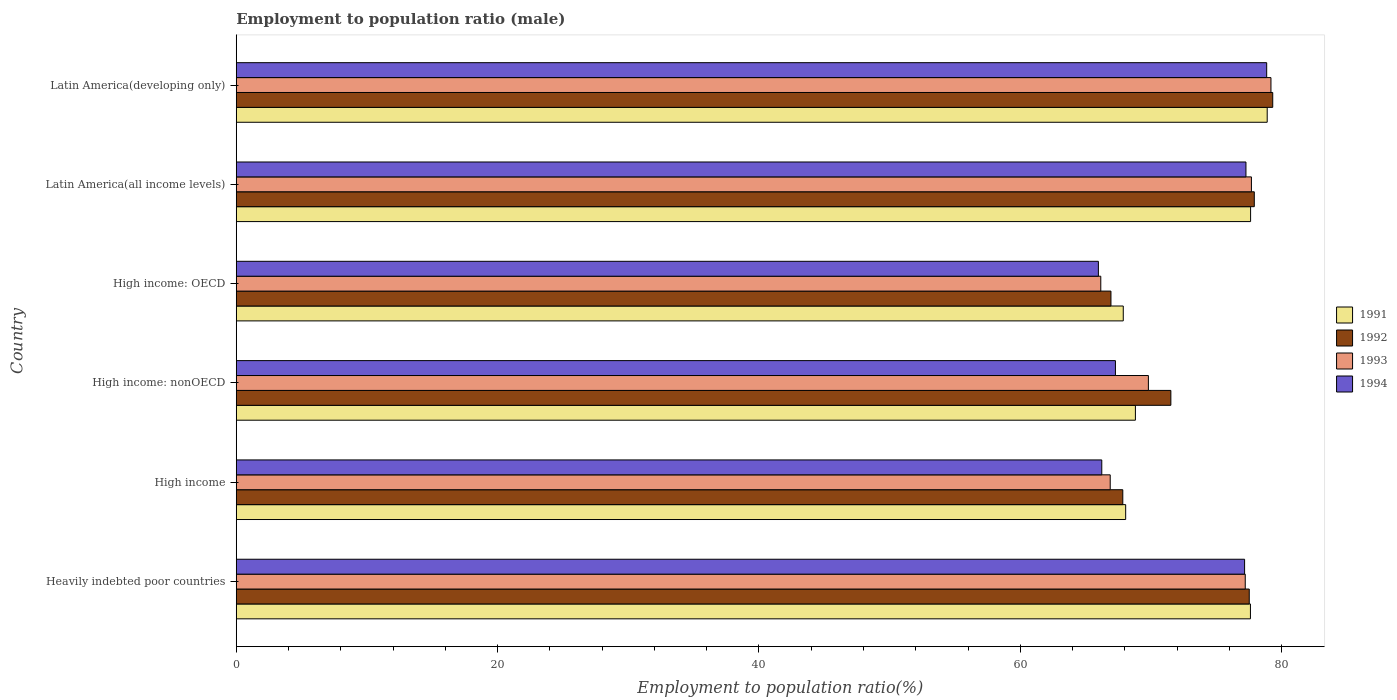Are the number of bars per tick equal to the number of legend labels?
Provide a short and direct response. Yes. Are the number of bars on each tick of the Y-axis equal?
Make the answer very short. Yes. What is the label of the 2nd group of bars from the top?
Provide a succinct answer. Latin America(all income levels). What is the employment to population ratio in 1993 in High income?
Keep it short and to the point. 66.88. Across all countries, what is the maximum employment to population ratio in 1994?
Offer a very short reply. 78.86. Across all countries, what is the minimum employment to population ratio in 1992?
Your response must be concise. 66.94. In which country was the employment to population ratio in 1992 maximum?
Make the answer very short. Latin America(developing only). In which country was the employment to population ratio in 1991 minimum?
Your answer should be compact. High income: OECD. What is the total employment to population ratio in 1992 in the graph?
Your answer should be very brief. 441.07. What is the difference between the employment to population ratio in 1994 in High income: OECD and that in High income: nonOECD?
Your response must be concise. -1.31. What is the difference between the employment to population ratio in 1994 in Heavily indebted poor countries and the employment to population ratio in 1993 in High income: OECD?
Provide a short and direct response. 11.01. What is the average employment to population ratio in 1991 per country?
Your response must be concise. 73.15. What is the difference between the employment to population ratio in 1994 and employment to population ratio in 1993 in Latin America(developing only)?
Keep it short and to the point. -0.33. What is the ratio of the employment to population ratio in 1994 in High income to that in Latin America(developing only)?
Offer a terse response. 0.84. Is the employment to population ratio in 1991 in High income less than that in High income: nonOECD?
Your answer should be very brief. Yes. Is the difference between the employment to population ratio in 1994 in High income and High income: nonOECD greater than the difference between the employment to population ratio in 1993 in High income and High income: nonOECD?
Your answer should be compact. Yes. What is the difference between the highest and the second highest employment to population ratio in 1991?
Provide a succinct answer. 1.27. What is the difference between the highest and the lowest employment to population ratio in 1992?
Make the answer very short. 12.38. In how many countries, is the employment to population ratio in 1993 greater than the average employment to population ratio in 1993 taken over all countries?
Ensure brevity in your answer.  3. Is the sum of the employment to population ratio in 1992 in Latin America(all income levels) and Latin America(developing only) greater than the maximum employment to population ratio in 1991 across all countries?
Offer a terse response. Yes. What does the 3rd bar from the top in Latin America(developing only) represents?
Offer a terse response. 1992. Is it the case that in every country, the sum of the employment to population ratio in 1992 and employment to population ratio in 1993 is greater than the employment to population ratio in 1991?
Your response must be concise. Yes. How many bars are there?
Provide a short and direct response. 24. Are all the bars in the graph horizontal?
Offer a very short reply. Yes. How many countries are there in the graph?
Give a very brief answer. 6. What is the difference between two consecutive major ticks on the X-axis?
Make the answer very short. 20. Does the graph contain any zero values?
Your answer should be compact. No. Does the graph contain grids?
Your answer should be very brief. No. How many legend labels are there?
Keep it short and to the point. 4. What is the title of the graph?
Your answer should be very brief. Employment to population ratio (male). What is the label or title of the X-axis?
Your answer should be very brief. Employment to population ratio(%). What is the label or title of the Y-axis?
Give a very brief answer. Country. What is the Employment to population ratio(%) in 1991 in Heavily indebted poor countries?
Ensure brevity in your answer.  77.61. What is the Employment to population ratio(%) of 1992 in Heavily indebted poor countries?
Your response must be concise. 77.52. What is the Employment to population ratio(%) in 1993 in Heavily indebted poor countries?
Make the answer very short. 77.22. What is the Employment to population ratio(%) of 1994 in Heavily indebted poor countries?
Your response must be concise. 77.17. What is the Employment to population ratio(%) in 1991 in High income?
Ensure brevity in your answer.  68.07. What is the Employment to population ratio(%) in 1992 in High income?
Keep it short and to the point. 67.85. What is the Employment to population ratio(%) of 1993 in High income?
Your answer should be compact. 66.88. What is the Employment to population ratio(%) in 1994 in High income?
Offer a terse response. 66.24. What is the Employment to population ratio(%) of 1991 in High income: nonOECD?
Offer a very short reply. 68.81. What is the Employment to population ratio(%) of 1992 in High income: nonOECD?
Offer a very short reply. 71.53. What is the Employment to population ratio(%) in 1993 in High income: nonOECD?
Make the answer very short. 69.81. What is the Employment to population ratio(%) in 1994 in High income: nonOECD?
Provide a succinct answer. 67.28. What is the Employment to population ratio(%) in 1991 in High income: OECD?
Offer a terse response. 67.88. What is the Employment to population ratio(%) in 1992 in High income: OECD?
Make the answer very short. 66.94. What is the Employment to population ratio(%) of 1993 in High income: OECD?
Your answer should be very brief. 66.16. What is the Employment to population ratio(%) of 1994 in High income: OECD?
Provide a succinct answer. 65.98. What is the Employment to population ratio(%) of 1991 in Latin America(all income levels)?
Make the answer very short. 77.63. What is the Employment to population ratio(%) in 1992 in Latin America(all income levels)?
Keep it short and to the point. 77.91. What is the Employment to population ratio(%) of 1993 in Latin America(all income levels)?
Make the answer very short. 77.69. What is the Employment to population ratio(%) of 1994 in Latin America(all income levels)?
Give a very brief answer. 77.27. What is the Employment to population ratio(%) in 1991 in Latin America(developing only)?
Your answer should be compact. 78.9. What is the Employment to population ratio(%) in 1992 in Latin America(developing only)?
Your answer should be very brief. 79.32. What is the Employment to population ratio(%) in 1993 in Latin America(developing only)?
Give a very brief answer. 79.19. What is the Employment to population ratio(%) in 1994 in Latin America(developing only)?
Give a very brief answer. 78.86. Across all countries, what is the maximum Employment to population ratio(%) in 1991?
Provide a short and direct response. 78.9. Across all countries, what is the maximum Employment to population ratio(%) of 1992?
Make the answer very short. 79.32. Across all countries, what is the maximum Employment to population ratio(%) in 1993?
Ensure brevity in your answer.  79.19. Across all countries, what is the maximum Employment to population ratio(%) of 1994?
Provide a succinct answer. 78.86. Across all countries, what is the minimum Employment to population ratio(%) of 1991?
Ensure brevity in your answer.  67.88. Across all countries, what is the minimum Employment to population ratio(%) in 1992?
Your response must be concise. 66.94. Across all countries, what is the minimum Employment to population ratio(%) in 1993?
Your answer should be compact. 66.16. Across all countries, what is the minimum Employment to population ratio(%) in 1994?
Provide a short and direct response. 65.98. What is the total Employment to population ratio(%) in 1991 in the graph?
Your answer should be very brief. 438.9. What is the total Employment to population ratio(%) of 1992 in the graph?
Give a very brief answer. 441.07. What is the total Employment to population ratio(%) of 1993 in the graph?
Provide a succinct answer. 436.95. What is the total Employment to population ratio(%) of 1994 in the graph?
Provide a succinct answer. 432.8. What is the difference between the Employment to population ratio(%) in 1991 in Heavily indebted poor countries and that in High income?
Provide a short and direct response. 9.55. What is the difference between the Employment to population ratio(%) of 1992 in Heavily indebted poor countries and that in High income?
Your answer should be compact. 9.68. What is the difference between the Employment to population ratio(%) in 1993 in Heavily indebted poor countries and that in High income?
Make the answer very short. 10.33. What is the difference between the Employment to population ratio(%) of 1994 in Heavily indebted poor countries and that in High income?
Offer a terse response. 10.93. What is the difference between the Employment to population ratio(%) of 1991 in Heavily indebted poor countries and that in High income: nonOECD?
Provide a short and direct response. 8.8. What is the difference between the Employment to population ratio(%) in 1992 in Heavily indebted poor countries and that in High income: nonOECD?
Keep it short and to the point. 6. What is the difference between the Employment to population ratio(%) of 1993 in Heavily indebted poor countries and that in High income: nonOECD?
Your answer should be very brief. 7.41. What is the difference between the Employment to population ratio(%) of 1994 in Heavily indebted poor countries and that in High income: nonOECD?
Your answer should be compact. 9.88. What is the difference between the Employment to population ratio(%) in 1991 in Heavily indebted poor countries and that in High income: OECD?
Ensure brevity in your answer.  9.73. What is the difference between the Employment to population ratio(%) of 1992 in Heavily indebted poor countries and that in High income: OECD?
Offer a very short reply. 10.58. What is the difference between the Employment to population ratio(%) of 1993 in Heavily indebted poor countries and that in High income: OECD?
Your answer should be very brief. 11.06. What is the difference between the Employment to population ratio(%) in 1994 in Heavily indebted poor countries and that in High income: OECD?
Provide a succinct answer. 11.19. What is the difference between the Employment to population ratio(%) of 1991 in Heavily indebted poor countries and that in Latin America(all income levels)?
Provide a short and direct response. -0.01. What is the difference between the Employment to population ratio(%) in 1992 in Heavily indebted poor countries and that in Latin America(all income levels)?
Your answer should be compact. -0.39. What is the difference between the Employment to population ratio(%) of 1993 in Heavily indebted poor countries and that in Latin America(all income levels)?
Your answer should be compact. -0.47. What is the difference between the Employment to population ratio(%) in 1994 in Heavily indebted poor countries and that in Latin America(all income levels)?
Provide a succinct answer. -0.1. What is the difference between the Employment to population ratio(%) in 1991 in Heavily indebted poor countries and that in Latin America(developing only)?
Your response must be concise. -1.28. What is the difference between the Employment to population ratio(%) in 1992 in Heavily indebted poor countries and that in Latin America(developing only)?
Make the answer very short. -1.8. What is the difference between the Employment to population ratio(%) in 1993 in Heavily indebted poor countries and that in Latin America(developing only)?
Offer a terse response. -1.97. What is the difference between the Employment to population ratio(%) in 1994 in Heavily indebted poor countries and that in Latin America(developing only)?
Your answer should be very brief. -1.69. What is the difference between the Employment to population ratio(%) in 1991 in High income and that in High income: nonOECD?
Provide a succinct answer. -0.74. What is the difference between the Employment to population ratio(%) of 1992 in High income and that in High income: nonOECD?
Your answer should be compact. -3.68. What is the difference between the Employment to population ratio(%) of 1993 in High income and that in High income: nonOECD?
Provide a short and direct response. -2.92. What is the difference between the Employment to population ratio(%) of 1994 in High income and that in High income: nonOECD?
Ensure brevity in your answer.  -1.05. What is the difference between the Employment to population ratio(%) in 1991 in High income and that in High income: OECD?
Offer a very short reply. 0.18. What is the difference between the Employment to population ratio(%) in 1992 in High income and that in High income: OECD?
Offer a terse response. 0.91. What is the difference between the Employment to population ratio(%) of 1993 in High income and that in High income: OECD?
Your answer should be very brief. 0.72. What is the difference between the Employment to population ratio(%) in 1994 in High income and that in High income: OECD?
Make the answer very short. 0.26. What is the difference between the Employment to population ratio(%) in 1991 in High income and that in Latin America(all income levels)?
Offer a terse response. -9.56. What is the difference between the Employment to population ratio(%) of 1992 in High income and that in Latin America(all income levels)?
Offer a very short reply. -10.06. What is the difference between the Employment to population ratio(%) in 1993 in High income and that in Latin America(all income levels)?
Your response must be concise. -10.81. What is the difference between the Employment to population ratio(%) of 1994 in High income and that in Latin America(all income levels)?
Provide a succinct answer. -11.03. What is the difference between the Employment to population ratio(%) of 1991 in High income and that in Latin America(developing only)?
Your response must be concise. -10.83. What is the difference between the Employment to population ratio(%) of 1992 in High income and that in Latin America(developing only)?
Offer a terse response. -11.47. What is the difference between the Employment to population ratio(%) in 1993 in High income and that in Latin America(developing only)?
Provide a short and direct response. -12.3. What is the difference between the Employment to population ratio(%) of 1994 in High income and that in Latin America(developing only)?
Offer a very short reply. -12.62. What is the difference between the Employment to population ratio(%) of 1991 in High income: nonOECD and that in High income: OECD?
Keep it short and to the point. 0.93. What is the difference between the Employment to population ratio(%) in 1992 in High income: nonOECD and that in High income: OECD?
Provide a succinct answer. 4.58. What is the difference between the Employment to population ratio(%) of 1993 in High income: nonOECD and that in High income: OECD?
Your response must be concise. 3.64. What is the difference between the Employment to population ratio(%) of 1994 in High income: nonOECD and that in High income: OECD?
Your response must be concise. 1.31. What is the difference between the Employment to population ratio(%) in 1991 in High income: nonOECD and that in Latin America(all income levels)?
Keep it short and to the point. -8.82. What is the difference between the Employment to population ratio(%) of 1992 in High income: nonOECD and that in Latin America(all income levels)?
Your answer should be very brief. -6.38. What is the difference between the Employment to population ratio(%) of 1993 in High income: nonOECD and that in Latin America(all income levels)?
Provide a succinct answer. -7.88. What is the difference between the Employment to population ratio(%) of 1994 in High income: nonOECD and that in Latin America(all income levels)?
Offer a very short reply. -9.99. What is the difference between the Employment to population ratio(%) in 1991 in High income: nonOECD and that in Latin America(developing only)?
Keep it short and to the point. -10.09. What is the difference between the Employment to population ratio(%) of 1992 in High income: nonOECD and that in Latin America(developing only)?
Provide a succinct answer. -7.8. What is the difference between the Employment to population ratio(%) of 1993 in High income: nonOECD and that in Latin America(developing only)?
Give a very brief answer. -9.38. What is the difference between the Employment to population ratio(%) in 1994 in High income: nonOECD and that in Latin America(developing only)?
Provide a short and direct response. -11.57. What is the difference between the Employment to population ratio(%) in 1991 in High income: OECD and that in Latin America(all income levels)?
Your answer should be compact. -9.75. What is the difference between the Employment to population ratio(%) of 1992 in High income: OECD and that in Latin America(all income levels)?
Your answer should be compact. -10.97. What is the difference between the Employment to population ratio(%) of 1993 in High income: OECD and that in Latin America(all income levels)?
Offer a very short reply. -11.53. What is the difference between the Employment to population ratio(%) in 1994 in High income: OECD and that in Latin America(all income levels)?
Provide a short and direct response. -11.29. What is the difference between the Employment to population ratio(%) in 1991 in High income: OECD and that in Latin America(developing only)?
Your answer should be very brief. -11.02. What is the difference between the Employment to population ratio(%) of 1992 in High income: OECD and that in Latin America(developing only)?
Provide a short and direct response. -12.38. What is the difference between the Employment to population ratio(%) of 1993 in High income: OECD and that in Latin America(developing only)?
Provide a short and direct response. -13.02. What is the difference between the Employment to population ratio(%) of 1994 in High income: OECD and that in Latin America(developing only)?
Keep it short and to the point. -12.88. What is the difference between the Employment to population ratio(%) of 1991 in Latin America(all income levels) and that in Latin America(developing only)?
Provide a succinct answer. -1.27. What is the difference between the Employment to population ratio(%) of 1992 in Latin America(all income levels) and that in Latin America(developing only)?
Your answer should be compact. -1.41. What is the difference between the Employment to population ratio(%) in 1993 in Latin America(all income levels) and that in Latin America(developing only)?
Give a very brief answer. -1.49. What is the difference between the Employment to population ratio(%) in 1994 in Latin America(all income levels) and that in Latin America(developing only)?
Keep it short and to the point. -1.59. What is the difference between the Employment to population ratio(%) in 1991 in Heavily indebted poor countries and the Employment to population ratio(%) in 1992 in High income?
Give a very brief answer. 9.77. What is the difference between the Employment to population ratio(%) of 1991 in Heavily indebted poor countries and the Employment to population ratio(%) of 1993 in High income?
Offer a terse response. 10.73. What is the difference between the Employment to population ratio(%) of 1991 in Heavily indebted poor countries and the Employment to population ratio(%) of 1994 in High income?
Your response must be concise. 11.38. What is the difference between the Employment to population ratio(%) of 1992 in Heavily indebted poor countries and the Employment to population ratio(%) of 1993 in High income?
Offer a terse response. 10.64. What is the difference between the Employment to population ratio(%) in 1992 in Heavily indebted poor countries and the Employment to population ratio(%) in 1994 in High income?
Provide a short and direct response. 11.29. What is the difference between the Employment to population ratio(%) of 1993 in Heavily indebted poor countries and the Employment to population ratio(%) of 1994 in High income?
Make the answer very short. 10.98. What is the difference between the Employment to population ratio(%) of 1991 in Heavily indebted poor countries and the Employment to population ratio(%) of 1992 in High income: nonOECD?
Your answer should be very brief. 6.09. What is the difference between the Employment to population ratio(%) in 1991 in Heavily indebted poor countries and the Employment to population ratio(%) in 1993 in High income: nonOECD?
Ensure brevity in your answer.  7.81. What is the difference between the Employment to population ratio(%) of 1991 in Heavily indebted poor countries and the Employment to population ratio(%) of 1994 in High income: nonOECD?
Provide a succinct answer. 10.33. What is the difference between the Employment to population ratio(%) in 1992 in Heavily indebted poor countries and the Employment to population ratio(%) in 1993 in High income: nonOECD?
Offer a terse response. 7.72. What is the difference between the Employment to population ratio(%) of 1992 in Heavily indebted poor countries and the Employment to population ratio(%) of 1994 in High income: nonOECD?
Provide a succinct answer. 10.24. What is the difference between the Employment to population ratio(%) of 1993 in Heavily indebted poor countries and the Employment to population ratio(%) of 1994 in High income: nonOECD?
Your response must be concise. 9.93. What is the difference between the Employment to population ratio(%) in 1991 in Heavily indebted poor countries and the Employment to population ratio(%) in 1992 in High income: OECD?
Keep it short and to the point. 10.67. What is the difference between the Employment to population ratio(%) in 1991 in Heavily indebted poor countries and the Employment to population ratio(%) in 1993 in High income: OECD?
Provide a short and direct response. 11.45. What is the difference between the Employment to population ratio(%) in 1991 in Heavily indebted poor countries and the Employment to population ratio(%) in 1994 in High income: OECD?
Give a very brief answer. 11.64. What is the difference between the Employment to population ratio(%) in 1992 in Heavily indebted poor countries and the Employment to population ratio(%) in 1993 in High income: OECD?
Your answer should be compact. 11.36. What is the difference between the Employment to population ratio(%) of 1992 in Heavily indebted poor countries and the Employment to population ratio(%) of 1994 in High income: OECD?
Make the answer very short. 11.55. What is the difference between the Employment to population ratio(%) in 1993 in Heavily indebted poor countries and the Employment to population ratio(%) in 1994 in High income: OECD?
Ensure brevity in your answer.  11.24. What is the difference between the Employment to population ratio(%) of 1991 in Heavily indebted poor countries and the Employment to population ratio(%) of 1992 in Latin America(all income levels)?
Offer a very short reply. -0.3. What is the difference between the Employment to population ratio(%) of 1991 in Heavily indebted poor countries and the Employment to population ratio(%) of 1993 in Latin America(all income levels)?
Your response must be concise. -0.08. What is the difference between the Employment to population ratio(%) in 1991 in Heavily indebted poor countries and the Employment to population ratio(%) in 1994 in Latin America(all income levels)?
Make the answer very short. 0.34. What is the difference between the Employment to population ratio(%) in 1992 in Heavily indebted poor countries and the Employment to population ratio(%) in 1993 in Latin America(all income levels)?
Provide a short and direct response. -0.17. What is the difference between the Employment to population ratio(%) in 1992 in Heavily indebted poor countries and the Employment to population ratio(%) in 1994 in Latin America(all income levels)?
Provide a succinct answer. 0.25. What is the difference between the Employment to population ratio(%) of 1993 in Heavily indebted poor countries and the Employment to population ratio(%) of 1994 in Latin America(all income levels)?
Provide a short and direct response. -0.05. What is the difference between the Employment to population ratio(%) in 1991 in Heavily indebted poor countries and the Employment to population ratio(%) in 1992 in Latin America(developing only)?
Give a very brief answer. -1.71. What is the difference between the Employment to population ratio(%) of 1991 in Heavily indebted poor countries and the Employment to population ratio(%) of 1993 in Latin America(developing only)?
Your answer should be very brief. -1.57. What is the difference between the Employment to population ratio(%) of 1991 in Heavily indebted poor countries and the Employment to population ratio(%) of 1994 in Latin America(developing only)?
Offer a very short reply. -1.24. What is the difference between the Employment to population ratio(%) of 1992 in Heavily indebted poor countries and the Employment to population ratio(%) of 1993 in Latin America(developing only)?
Offer a terse response. -1.66. What is the difference between the Employment to population ratio(%) in 1992 in Heavily indebted poor countries and the Employment to population ratio(%) in 1994 in Latin America(developing only)?
Your answer should be very brief. -1.33. What is the difference between the Employment to population ratio(%) of 1993 in Heavily indebted poor countries and the Employment to population ratio(%) of 1994 in Latin America(developing only)?
Your answer should be compact. -1.64. What is the difference between the Employment to population ratio(%) of 1991 in High income and the Employment to population ratio(%) of 1992 in High income: nonOECD?
Give a very brief answer. -3.46. What is the difference between the Employment to population ratio(%) in 1991 in High income and the Employment to population ratio(%) in 1993 in High income: nonOECD?
Keep it short and to the point. -1.74. What is the difference between the Employment to population ratio(%) of 1991 in High income and the Employment to population ratio(%) of 1994 in High income: nonOECD?
Ensure brevity in your answer.  0.78. What is the difference between the Employment to population ratio(%) of 1992 in High income and the Employment to population ratio(%) of 1993 in High income: nonOECD?
Your answer should be very brief. -1.96. What is the difference between the Employment to population ratio(%) in 1992 in High income and the Employment to population ratio(%) in 1994 in High income: nonOECD?
Ensure brevity in your answer.  0.56. What is the difference between the Employment to population ratio(%) of 1993 in High income and the Employment to population ratio(%) of 1994 in High income: nonOECD?
Offer a very short reply. -0.4. What is the difference between the Employment to population ratio(%) of 1991 in High income and the Employment to population ratio(%) of 1992 in High income: OECD?
Provide a short and direct response. 1.13. What is the difference between the Employment to population ratio(%) in 1991 in High income and the Employment to population ratio(%) in 1993 in High income: OECD?
Your answer should be very brief. 1.91. What is the difference between the Employment to population ratio(%) in 1991 in High income and the Employment to population ratio(%) in 1994 in High income: OECD?
Ensure brevity in your answer.  2.09. What is the difference between the Employment to population ratio(%) in 1992 in High income and the Employment to population ratio(%) in 1993 in High income: OECD?
Give a very brief answer. 1.69. What is the difference between the Employment to population ratio(%) of 1992 in High income and the Employment to population ratio(%) of 1994 in High income: OECD?
Provide a succinct answer. 1.87. What is the difference between the Employment to population ratio(%) of 1993 in High income and the Employment to population ratio(%) of 1994 in High income: OECD?
Provide a short and direct response. 0.91. What is the difference between the Employment to population ratio(%) in 1991 in High income and the Employment to population ratio(%) in 1992 in Latin America(all income levels)?
Ensure brevity in your answer.  -9.84. What is the difference between the Employment to population ratio(%) of 1991 in High income and the Employment to population ratio(%) of 1993 in Latin America(all income levels)?
Ensure brevity in your answer.  -9.62. What is the difference between the Employment to population ratio(%) in 1991 in High income and the Employment to population ratio(%) in 1994 in Latin America(all income levels)?
Your answer should be compact. -9.2. What is the difference between the Employment to population ratio(%) in 1992 in High income and the Employment to population ratio(%) in 1993 in Latin America(all income levels)?
Give a very brief answer. -9.84. What is the difference between the Employment to population ratio(%) of 1992 in High income and the Employment to population ratio(%) of 1994 in Latin America(all income levels)?
Your answer should be compact. -9.42. What is the difference between the Employment to population ratio(%) of 1993 in High income and the Employment to population ratio(%) of 1994 in Latin America(all income levels)?
Offer a terse response. -10.39. What is the difference between the Employment to population ratio(%) of 1991 in High income and the Employment to population ratio(%) of 1992 in Latin America(developing only)?
Offer a very short reply. -11.25. What is the difference between the Employment to population ratio(%) in 1991 in High income and the Employment to population ratio(%) in 1993 in Latin America(developing only)?
Give a very brief answer. -11.12. What is the difference between the Employment to population ratio(%) of 1991 in High income and the Employment to population ratio(%) of 1994 in Latin America(developing only)?
Make the answer very short. -10.79. What is the difference between the Employment to population ratio(%) in 1992 in High income and the Employment to population ratio(%) in 1993 in Latin America(developing only)?
Ensure brevity in your answer.  -11.34. What is the difference between the Employment to population ratio(%) in 1992 in High income and the Employment to population ratio(%) in 1994 in Latin America(developing only)?
Provide a short and direct response. -11.01. What is the difference between the Employment to population ratio(%) in 1993 in High income and the Employment to population ratio(%) in 1994 in Latin America(developing only)?
Your response must be concise. -11.97. What is the difference between the Employment to population ratio(%) in 1991 in High income: nonOECD and the Employment to population ratio(%) in 1992 in High income: OECD?
Your answer should be compact. 1.87. What is the difference between the Employment to population ratio(%) of 1991 in High income: nonOECD and the Employment to population ratio(%) of 1993 in High income: OECD?
Keep it short and to the point. 2.65. What is the difference between the Employment to population ratio(%) in 1991 in High income: nonOECD and the Employment to population ratio(%) in 1994 in High income: OECD?
Ensure brevity in your answer.  2.83. What is the difference between the Employment to population ratio(%) in 1992 in High income: nonOECD and the Employment to population ratio(%) in 1993 in High income: OECD?
Your response must be concise. 5.36. What is the difference between the Employment to population ratio(%) of 1992 in High income: nonOECD and the Employment to population ratio(%) of 1994 in High income: OECD?
Ensure brevity in your answer.  5.55. What is the difference between the Employment to population ratio(%) of 1993 in High income: nonOECD and the Employment to population ratio(%) of 1994 in High income: OECD?
Make the answer very short. 3.83. What is the difference between the Employment to population ratio(%) in 1991 in High income: nonOECD and the Employment to population ratio(%) in 1992 in Latin America(all income levels)?
Give a very brief answer. -9.1. What is the difference between the Employment to population ratio(%) in 1991 in High income: nonOECD and the Employment to population ratio(%) in 1993 in Latin America(all income levels)?
Give a very brief answer. -8.88. What is the difference between the Employment to population ratio(%) of 1991 in High income: nonOECD and the Employment to population ratio(%) of 1994 in Latin America(all income levels)?
Your answer should be very brief. -8.46. What is the difference between the Employment to population ratio(%) in 1992 in High income: nonOECD and the Employment to population ratio(%) in 1993 in Latin America(all income levels)?
Your answer should be compact. -6.17. What is the difference between the Employment to population ratio(%) of 1992 in High income: nonOECD and the Employment to population ratio(%) of 1994 in Latin America(all income levels)?
Keep it short and to the point. -5.75. What is the difference between the Employment to population ratio(%) of 1993 in High income: nonOECD and the Employment to population ratio(%) of 1994 in Latin America(all income levels)?
Give a very brief answer. -7.47. What is the difference between the Employment to population ratio(%) in 1991 in High income: nonOECD and the Employment to population ratio(%) in 1992 in Latin America(developing only)?
Your response must be concise. -10.51. What is the difference between the Employment to population ratio(%) in 1991 in High income: nonOECD and the Employment to population ratio(%) in 1993 in Latin America(developing only)?
Your answer should be very brief. -10.37. What is the difference between the Employment to population ratio(%) of 1991 in High income: nonOECD and the Employment to population ratio(%) of 1994 in Latin America(developing only)?
Give a very brief answer. -10.05. What is the difference between the Employment to population ratio(%) of 1992 in High income: nonOECD and the Employment to population ratio(%) of 1993 in Latin America(developing only)?
Your answer should be compact. -7.66. What is the difference between the Employment to population ratio(%) in 1992 in High income: nonOECD and the Employment to population ratio(%) in 1994 in Latin America(developing only)?
Make the answer very short. -7.33. What is the difference between the Employment to population ratio(%) of 1993 in High income: nonOECD and the Employment to population ratio(%) of 1994 in Latin America(developing only)?
Give a very brief answer. -9.05. What is the difference between the Employment to population ratio(%) of 1991 in High income: OECD and the Employment to population ratio(%) of 1992 in Latin America(all income levels)?
Offer a terse response. -10.03. What is the difference between the Employment to population ratio(%) of 1991 in High income: OECD and the Employment to population ratio(%) of 1993 in Latin America(all income levels)?
Keep it short and to the point. -9.81. What is the difference between the Employment to population ratio(%) of 1991 in High income: OECD and the Employment to population ratio(%) of 1994 in Latin America(all income levels)?
Offer a terse response. -9.39. What is the difference between the Employment to population ratio(%) of 1992 in High income: OECD and the Employment to population ratio(%) of 1993 in Latin America(all income levels)?
Your response must be concise. -10.75. What is the difference between the Employment to population ratio(%) of 1992 in High income: OECD and the Employment to population ratio(%) of 1994 in Latin America(all income levels)?
Give a very brief answer. -10.33. What is the difference between the Employment to population ratio(%) of 1993 in High income: OECD and the Employment to population ratio(%) of 1994 in Latin America(all income levels)?
Your answer should be very brief. -11.11. What is the difference between the Employment to population ratio(%) in 1991 in High income: OECD and the Employment to population ratio(%) in 1992 in Latin America(developing only)?
Provide a succinct answer. -11.44. What is the difference between the Employment to population ratio(%) in 1991 in High income: OECD and the Employment to population ratio(%) in 1993 in Latin America(developing only)?
Provide a succinct answer. -11.3. What is the difference between the Employment to population ratio(%) in 1991 in High income: OECD and the Employment to population ratio(%) in 1994 in Latin America(developing only)?
Offer a terse response. -10.98. What is the difference between the Employment to population ratio(%) in 1992 in High income: OECD and the Employment to population ratio(%) in 1993 in Latin America(developing only)?
Provide a short and direct response. -12.25. What is the difference between the Employment to population ratio(%) of 1992 in High income: OECD and the Employment to population ratio(%) of 1994 in Latin America(developing only)?
Make the answer very short. -11.92. What is the difference between the Employment to population ratio(%) of 1993 in High income: OECD and the Employment to population ratio(%) of 1994 in Latin America(developing only)?
Offer a very short reply. -12.7. What is the difference between the Employment to population ratio(%) of 1991 in Latin America(all income levels) and the Employment to population ratio(%) of 1992 in Latin America(developing only)?
Ensure brevity in your answer.  -1.69. What is the difference between the Employment to population ratio(%) in 1991 in Latin America(all income levels) and the Employment to population ratio(%) in 1993 in Latin America(developing only)?
Your response must be concise. -1.56. What is the difference between the Employment to population ratio(%) in 1991 in Latin America(all income levels) and the Employment to population ratio(%) in 1994 in Latin America(developing only)?
Keep it short and to the point. -1.23. What is the difference between the Employment to population ratio(%) of 1992 in Latin America(all income levels) and the Employment to population ratio(%) of 1993 in Latin America(developing only)?
Provide a short and direct response. -1.28. What is the difference between the Employment to population ratio(%) in 1992 in Latin America(all income levels) and the Employment to population ratio(%) in 1994 in Latin America(developing only)?
Give a very brief answer. -0.95. What is the difference between the Employment to population ratio(%) in 1993 in Latin America(all income levels) and the Employment to population ratio(%) in 1994 in Latin America(developing only)?
Keep it short and to the point. -1.17. What is the average Employment to population ratio(%) of 1991 per country?
Offer a very short reply. 73.15. What is the average Employment to population ratio(%) in 1992 per country?
Provide a short and direct response. 73.51. What is the average Employment to population ratio(%) in 1993 per country?
Offer a very short reply. 72.82. What is the average Employment to population ratio(%) of 1994 per country?
Give a very brief answer. 72.13. What is the difference between the Employment to population ratio(%) of 1991 and Employment to population ratio(%) of 1992 in Heavily indebted poor countries?
Keep it short and to the point. 0.09. What is the difference between the Employment to population ratio(%) in 1991 and Employment to population ratio(%) in 1993 in Heavily indebted poor countries?
Offer a very short reply. 0.4. What is the difference between the Employment to population ratio(%) in 1991 and Employment to population ratio(%) in 1994 in Heavily indebted poor countries?
Your answer should be very brief. 0.45. What is the difference between the Employment to population ratio(%) of 1992 and Employment to population ratio(%) of 1993 in Heavily indebted poor countries?
Your response must be concise. 0.31. What is the difference between the Employment to population ratio(%) of 1992 and Employment to population ratio(%) of 1994 in Heavily indebted poor countries?
Your response must be concise. 0.36. What is the difference between the Employment to population ratio(%) of 1993 and Employment to population ratio(%) of 1994 in Heavily indebted poor countries?
Provide a short and direct response. 0.05. What is the difference between the Employment to population ratio(%) in 1991 and Employment to population ratio(%) in 1992 in High income?
Give a very brief answer. 0.22. What is the difference between the Employment to population ratio(%) in 1991 and Employment to population ratio(%) in 1993 in High income?
Provide a short and direct response. 1.18. What is the difference between the Employment to population ratio(%) of 1991 and Employment to population ratio(%) of 1994 in High income?
Your answer should be compact. 1.83. What is the difference between the Employment to population ratio(%) in 1992 and Employment to population ratio(%) in 1994 in High income?
Keep it short and to the point. 1.61. What is the difference between the Employment to population ratio(%) in 1993 and Employment to population ratio(%) in 1994 in High income?
Give a very brief answer. 0.65. What is the difference between the Employment to population ratio(%) of 1991 and Employment to population ratio(%) of 1992 in High income: nonOECD?
Provide a short and direct response. -2.71. What is the difference between the Employment to population ratio(%) of 1991 and Employment to population ratio(%) of 1993 in High income: nonOECD?
Give a very brief answer. -0.99. What is the difference between the Employment to population ratio(%) in 1991 and Employment to population ratio(%) in 1994 in High income: nonOECD?
Ensure brevity in your answer.  1.53. What is the difference between the Employment to population ratio(%) of 1992 and Employment to population ratio(%) of 1993 in High income: nonOECD?
Your response must be concise. 1.72. What is the difference between the Employment to population ratio(%) of 1992 and Employment to population ratio(%) of 1994 in High income: nonOECD?
Give a very brief answer. 4.24. What is the difference between the Employment to population ratio(%) of 1993 and Employment to population ratio(%) of 1994 in High income: nonOECD?
Offer a terse response. 2.52. What is the difference between the Employment to population ratio(%) in 1991 and Employment to population ratio(%) in 1992 in High income: OECD?
Your answer should be very brief. 0.94. What is the difference between the Employment to population ratio(%) of 1991 and Employment to population ratio(%) of 1993 in High income: OECD?
Keep it short and to the point. 1.72. What is the difference between the Employment to population ratio(%) in 1991 and Employment to population ratio(%) in 1994 in High income: OECD?
Provide a succinct answer. 1.9. What is the difference between the Employment to population ratio(%) of 1992 and Employment to population ratio(%) of 1993 in High income: OECD?
Your answer should be very brief. 0.78. What is the difference between the Employment to population ratio(%) of 1992 and Employment to population ratio(%) of 1994 in High income: OECD?
Offer a very short reply. 0.96. What is the difference between the Employment to population ratio(%) in 1993 and Employment to population ratio(%) in 1994 in High income: OECD?
Provide a short and direct response. 0.18. What is the difference between the Employment to population ratio(%) in 1991 and Employment to population ratio(%) in 1992 in Latin America(all income levels)?
Your answer should be compact. -0.28. What is the difference between the Employment to population ratio(%) in 1991 and Employment to population ratio(%) in 1993 in Latin America(all income levels)?
Your response must be concise. -0.06. What is the difference between the Employment to population ratio(%) in 1991 and Employment to population ratio(%) in 1994 in Latin America(all income levels)?
Provide a short and direct response. 0.36. What is the difference between the Employment to population ratio(%) of 1992 and Employment to population ratio(%) of 1993 in Latin America(all income levels)?
Make the answer very short. 0.22. What is the difference between the Employment to population ratio(%) of 1992 and Employment to population ratio(%) of 1994 in Latin America(all income levels)?
Your answer should be very brief. 0.64. What is the difference between the Employment to population ratio(%) of 1993 and Employment to population ratio(%) of 1994 in Latin America(all income levels)?
Provide a succinct answer. 0.42. What is the difference between the Employment to population ratio(%) of 1991 and Employment to population ratio(%) of 1992 in Latin America(developing only)?
Offer a terse response. -0.42. What is the difference between the Employment to population ratio(%) in 1991 and Employment to population ratio(%) in 1993 in Latin America(developing only)?
Give a very brief answer. -0.29. What is the difference between the Employment to population ratio(%) of 1991 and Employment to population ratio(%) of 1994 in Latin America(developing only)?
Offer a terse response. 0.04. What is the difference between the Employment to population ratio(%) of 1992 and Employment to population ratio(%) of 1993 in Latin America(developing only)?
Keep it short and to the point. 0.14. What is the difference between the Employment to population ratio(%) of 1992 and Employment to population ratio(%) of 1994 in Latin America(developing only)?
Keep it short and to the point. 0.46. What is the difference between the Employment to population ratio(%) of 1993 and Employment to population ratio(%) of 1994 in Latin America(developing only)?
Give a very brief answer. 0.33. What is the ratio of the Employment to population ratio(%) of 1991 in Heavily indebted poor countries to that in High income?
Make the answer very short. 1.14. What is the ratio of the Employment to population ratio(%) of 1992 in Heavily indebted poor countries to that in High income?
Keep it short and to the point. 1.14. What is the ratio of the Employment to population ratio(%) of 1993 in Heavily indebted poor countries to that in High income?
Your answer should be very brief. 1.15. What is the ratio of the Employment to population ratio(%) in 1994 in Heavily indebted poor countries to that in High income?
Ensure brevity in your answer.  1.17. What is the ratio of the Employment to population ratio(%) of 1991 in Heavily indebted poor countries to that in High income: nonOECD?
Your response must be concise. 1.13. What is the ratio of the Employment to population ratio(%) of 1992 in Heavily indebted poor countries to that in High income: nonOECD?
Provide a succinct answer. 1.08. What is the ratio of the Employment to population ratio(%) of 1993 in Heavily indebted poor countries to that in High income: nonOECD?
Your answer should be compact. 1.11. What is the ratio of the Employment to population ratio(%) in 1994 in Heavily indebted poor countries to that in High income: nonOECD?
Provide a short and direct response. 1.15. What is the ratio of the Employment to population ratio(%) of 1991 in Heavily indebted poor countries to that in High income: OECD?
Your response must be concise. 1.14. What is the ratio of the Employment to population ratio(%) of 1992 in Heavily indebted poor countries to that in High income: OECD?
Your answer should be very brief. 1.16. What is the ratio of the Employment to population ratio(%) of 1993 in Heavily indebted poor countries to that in High income: OECD?
Ensure brevity in your answer.  1.17. What is the ratio of the Employment to population ratio(%) in 1994 in Heavily indebted poor countries to that in High income: OECD?
Offer a very short reply. 1.17. What is the ratio of the Employment to population ratio(%) in 1991 in Heavily indebted poor countries to that in Latin America(all income levels)?
Keep it short and to the point. 1. What is the ratio of the Employment to population ratio(%) of 1993 in Heavily indebted poor countries to that in Latin America(all income levels)?
Provide a short and direct response. 0.99. What is the ratio of the Employment to population ratio(%) of 1994 in Heavily indebted poor countries to that in Latin America(all income levels)?
Provide a succinct answer. 1. What is the ratio of the Employment to population ratio(%) of 1991 in Heavily indebted poor countries to that in Latin America(developing only)?
Ensure brevity in your answer.  0.98. What is the ratio of the Employment to population ratio(%) of 1992 in Heavily indebted poor countries to that in Latin America(developing only)?
Give a very brief answer. 0.98. What is the ratio of the Employment to population ratio(%) of 1993 in Heavily indebted poor countries to that in Latin America(developing only)?
Ensure brevity in your answer.  0.98. What is the ratio of the Employment to population ratio(%) of 1994 in Heavily indebted poor countries to that in Latin America(developing only)?
Make the answer very short. 0.98. What is the ratio of the Employment to population ratio(%) in 1991 in High income to that in High income: nonOECD?
Make the answer very short. 0.99. What is the ratio of the Employment to population ratio(%) in 1992 in High income to that in High income: nonOECD?
Offer a terse response. 0.95. What is the ratio of the Employment to population ratio(%) of 1993 in High income to that in High income: nonOECD?
Offer a very short reply. 0.96. What is the ratio of the Employment to population ratio(%) in 1994 in High income to that in High income: nonOECD?
Make the answer very short. 0.98. What is the ratio of the Employment to population ratio(%) in 1992 in High income to that in High income: OECD?
Provide a short and direct response. 1.01. What is the ratio of the Employment to population ratio(%) in 1993 in High income to that in High income: OECD?
Your response must be concise. 1.01. What is the ratio of the Employment to population ratio(%) of 1994 in High income to that in High income: OECD?
Your answer should be very brief. 1. What is the ratio of the Employment to population ratio(%) in 1991 in High income to that in Latin America(all income levels)?
Offer a terse response. 0.88. What is the ratio of the Employment to population ratio(%) in 1992 in High income to that in Latin America(all income levels)?
Provide a succinct answer. 0.87. What is the ratio of the Employment to population ratio(%) in 1993 in High income to that in Latin America(all income levels)?
Keep it short and to the point. 0.86. What is the ratio of the Employment to population ratio(%) in 1994 in High income to that in Latin America(all income levels)?
Keep it short and to the point. 0.86. What is the ratio of the Employment to population ratio(%) in 1991 in High income to that in Latin America(developing only)?
Your answer should be very brief. 0.86. What is the ratio of the Employment to population ratio(%) in 1992 in High income to that in Latin America(developing only)?
Your answer should be very brief. 0.86. What is the ratio of the Employment to population ratio(%) in 1993 in High income to that in Latin America(developing only)?
Provide a succinct answer. 0.84. What is the ratio of the Employment to population ratio(%) in 1994 in High income to that in Latin America(developing only)?
Keep it short and to the point. 0.84. What is the ratio of the Employment to population ratio(%) in 1991 in High income: nonOECD to that in High income: OECD?
Ensure brevity in your answer.  1.01. What is the ratio of the Employment to population ratio(%) of 1992 in High income: nonOECD to that in High income: OECD?
Your response must be concise. 1.07. What is the ratio of the Employment to population ratio(%) in 1993 in High income: nonOECD to that in High income: OECD?
Your answer should be very brief. 1.06. What is the ratio of the Employment to population ratio(%) of 1994 in High income: nonOECD to that in High income: OECD?
Keep it short and to the point. 1.02. What is the ratio of the Employment to population ratio(%) in 1991 in High income: nonOECD to that in Latin America(all income levels)?
Give a very brief answer. 0.89. What is the ratio of the Employment to population ratio(%) in 1992 in High income: nonOECD to that in Latin America(all income levels)?
Offer a very short reply. 0.92. What is the ratio of the Employment to population ratio(%) in 1993 in High income: nonOECD to that in Latin America(all income levels)?
Make the answer very short. 0.9. What is the ratio of the Employment to population ratio(%) in 1994 in High income: nonOECD to that in Latin America(all income levels)?
Your answer should be very brief. 0.87. What is the ratio of the Employment to population ratio(%) of 1991 in High income: nonOECD to that in Latin America(developing only)?
Keep it short and to the point. 0.87. What is the ratio of the Employment to population ratio(%) in 1992 in High income: nonOECD to that in Latin America(developing only)?
Offer a very short reply. 0.9. What is the ratio of the Employment to population ratio(%) of 1993 in High income: nonOECD to that in Latin America(developing only)?
Provide a succinct answer. 0.88. What is the ratio of the Employment to population ratio(%) in 1994 in High income: nonOECD to that in Latin America(developing only)?
Provide a short and direct response. 0.85. What is the ratio of the Employment to population ratio(%) of 1991 in High income: OECD to that in Latin America(all income levels)?
Make the answer very short. 0.87. What is the ratio of the Employment to population ratio(%) of 1992 in High income: OECD to that in Latin America(all income levels)?
Offer a very short reply. 0.86. What is the ratio of the Employment to population ratio(%) in 1993 in High income: OECD to that in Latin America(all income levels)?
Make the answer very short. 0.85. What is the ratio of the Employment to population ratio(%) in 1994 in High income: OECD to that in Latin America(all income levels)?
Your answer should be compact. 0.85. What is the ratio of the Employment to population ratio(%) in 1991 in High income: OECD to that in Latin America(developing only)?
Your answer should be compact. 0.86. What is the ratio of the Employment to population ratio(%) of 1992 in High income: OECD to that in Latin America(developing only)?
Your answer should be very brief. 0.84. What is the ratio of the Employment to population ratio(%) of 1993 in High income: OECD to that in Latin America(developing only)?
Your response must be concise. 0.84. What is the ratio of the Employment to population ratio(%) in 1994 in High income: OECD to that in Latin America(developing only)?
Offer a terse response. 0.84. What is the ratio of the Employment to population ratio(%) in 1991 in Latin America(all income levels) to that in Latin America(developing only)?
Offer a very short reply. 0.98. What is the ratio of the Employment to population ratio(%) in 1992 in Latin America(all income levels) to that in Latin America(developing only)?
Provide a short and direct response. 0.98. What is the ratio of the Employment to population ratio(%) in 1993 in Latin America(all income levels) to that in Latin America(developing only)?
Offer a terse response. 0.98. What is the ratio of the Employment to population ratio(%) of 1994 in Latin America(all income levels) to that in Latin America(developing only)?
Offer a terse response. 0.98. What is the difference between the highest and the second highest Employment to population ratio(%) of 1991?
Keep it short and to the point. 1.27. What is the difference between the highest and the second highest Employment to population ratio(%) in 1992?
Your answer should be compact. 1.41. What is the difference between the highest and the second highest Employment to population ratio(%) of 1993?
Your answer should be very brief. 1.49. What is the difference between the highest and the second highest Employment to population ratio(%) in 1994?
Ensure brevity in your answer.  1.59. What is the difference between the highest and the lowest Employment to population ratio(%) of 1991?
Provide a succinct answer. 11.02. What is the difference between the highest and the lowest Employment to population ratio(%) of 1992?
Provide a succinct answer. 12.38. What is the difference between the highest and the lowest Employment to population ratio(%) in 1993?
Offer a terse response. 13.02. What is the difference between the highest and the lowest Employment to population ratio(%) of 1994?
Make the answer very short. 12.88. 